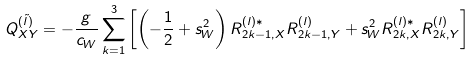<formula> <loc_0><loc_0><loc_500><loc_500>Q _ { X Y } ^ { ( \tilde { l } ) } = - \frac { g } { c _ { W } } \sum _ { k = 1 } ^ { 3 } \left [ \left ( - \frac { 1 } { 2 } + s _ { W } ^ { 2 } \right ) R _ { 2 k - 1 , X } ^ { ( l ) \ast } R _ { 2 k - 1 , Y } ^ { ( l ) } + s _ { W } ^ { 2 } R _ { 2 k , X } ^ { ( l ) \ast } R _ { 2 k , Y } ^ { ( l ) } \right ]</formula> 